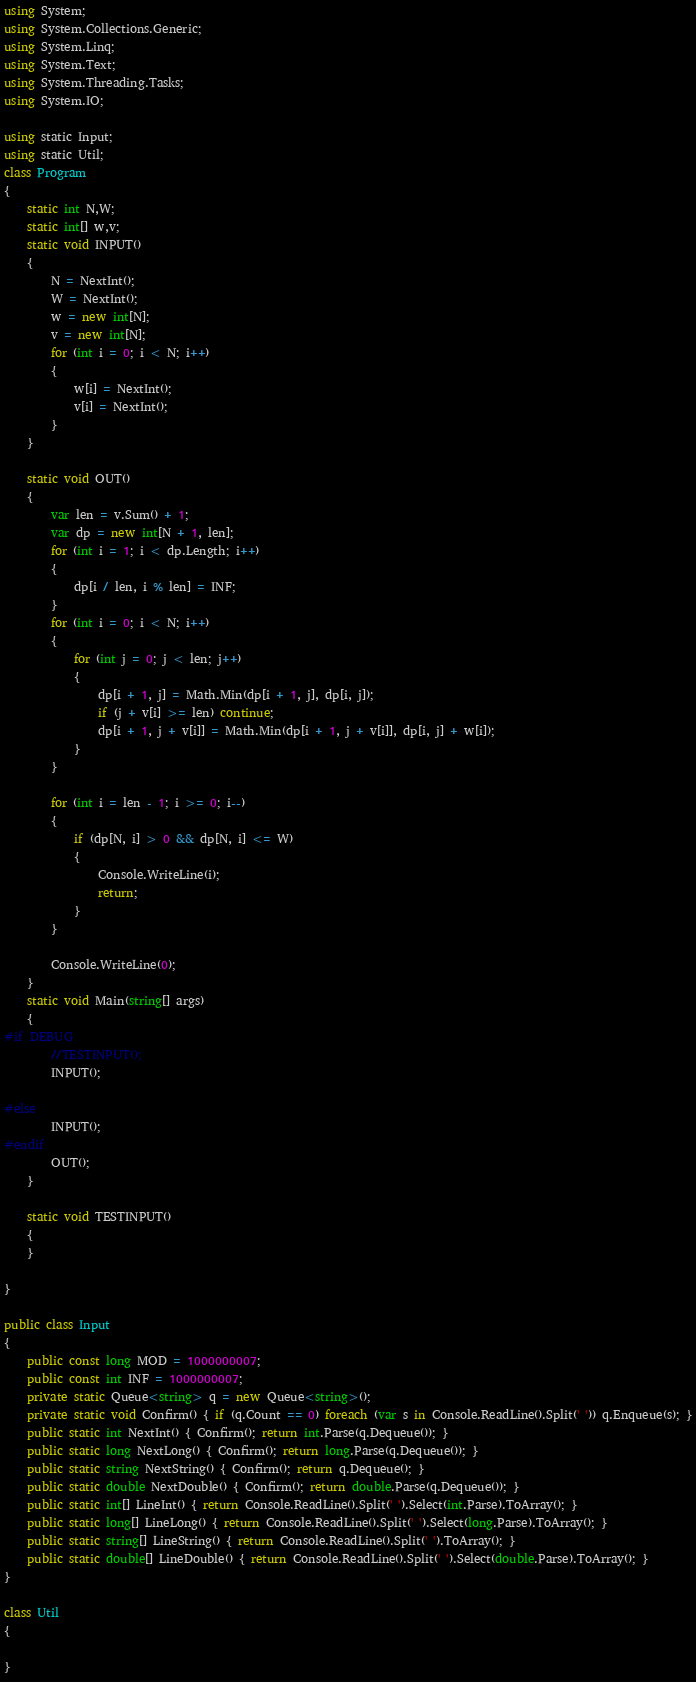Convert code to text. <code><loc_0><loc_0><loc_500><loc_500><_C#_>using System;
using System.Collections.Generic;
using System.Linq;
using System.Text;
using System.Threading.Tasks;
using System.IO;

using static Input;
using static Util;
class Program
{
    static int N,W;
    static int[] w,v;
    static void INPUT()
    {
        N = NextInt();
        W = NextInt();
        w = new int[N];
        v = new int[N];
        for (int i = 0; i < N; i++)
        {
            w[i] = NextInt();
            v[i] = NextInt();
        }
    }

    static void OUT()
    {
        var len = v.Sum() + 1;
        var dp = new int[N + 1, len];
        for (int i = 1; i < dp.Length; i++)
        {
            dp[i / len, i % len] = INF;
        }
        for (int i = 0; i < N; i++)
        {
            for (int j = 0; j < len; j++)
            {
                dp[i + 1, j] = Math.Min(dp[i + 1, j], dp[i, j]);
                if (j + v[i] >= len) continue;
                dp[i + 1, j + v[i]] = Math.Min(dp[i + 1, j + v[i]], dp[i, j] + w[i]);
            }
        }

        for (int i = len - 1; i >= 0; i--)
        {
            if (dp[N, i] > 0 && dp[N, i] <= W)
            {
                Console.WriteLine(i);
                return;
            }
        }

        Console.WriteLine(0);
    }
    static void Main(string[] args)
    {
#if DEBUG  
        //TESTINPUT();
        INPUT();

#else
        INPUT();
#endif
        OUT();
    }

    static void TESTINPUT()
    {
    }

}

public class Input
{
    public const long MOD = 1000000007;
    public const int INF = 1000000007;
    private static Queue<string> q = new Queue<string>();
    private static void Confirm() { if (q.Count == 0) foreach (var s in Console.ReadLine().Split(' ')) q.Enqueue(s); }
    public static int NextInt() { Confirm(); return int.Parse(q.Dequeue()); }
    public static long NextLong() { Confirm(); return long.Parse(q.Dequeue()); }
    public static string NextString() { Confirm(); return q.Dequeue(); }
    public static double NextDouble() { Confirm(); return double.Parse(q.Dequeue()); }
    public static int[] LineInt() { return Console.ReadLine().Split(' ').Select(int.Parse).ToArray(); }
    public static long[] LineLong() { return Console.ReadLine().Split(' ').Select(long.Parse).ToArray(); }
    public static string[] LineString() { return Console.ReadLine().Split(' ').ToArray(); }
    public static double[] LineDouble() { return Console.ReadLine().Split(' ').Select(double.Parse).ToArray(); }
}

class Util
{

}


</code> 